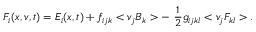Convert formula to latex. <formula><loc_0><loc_0><loc_500><loc_500>F _ { i } ( x , v , t ) = E _ { i } ( x , t ) + f _ { i j k } < v _ { j } B _ { k } > - \frac { 1 } { 2 } g _ { i j k l } < v _ { j } F _ { k l } > .</formula> 